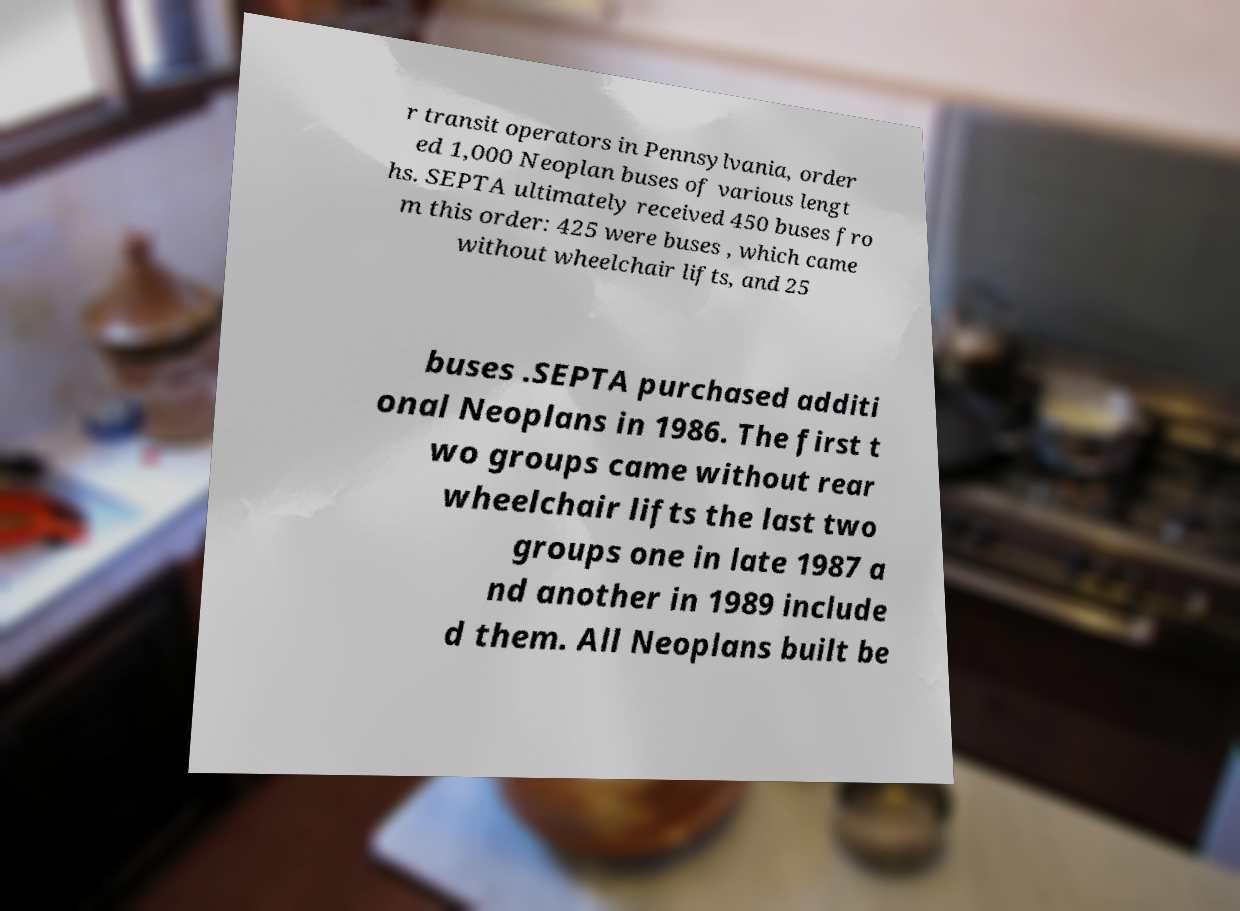Could you extract and type out the text from this image? r transit operators in Pennsylvania, order ed 1,000 Neoplan buses of various lengt hs. SEPTA ultimately received 450 buses fro m this order: 425 were buses , which came without wheelchair lifts, and 25 buses .SEPTA purchased additi onal Neoplans in 1986. The first t wo groups came without rear wheelchair lifts the last two groups one in late 1987 a nd another in 1989 include d them. All Neoplans built be 